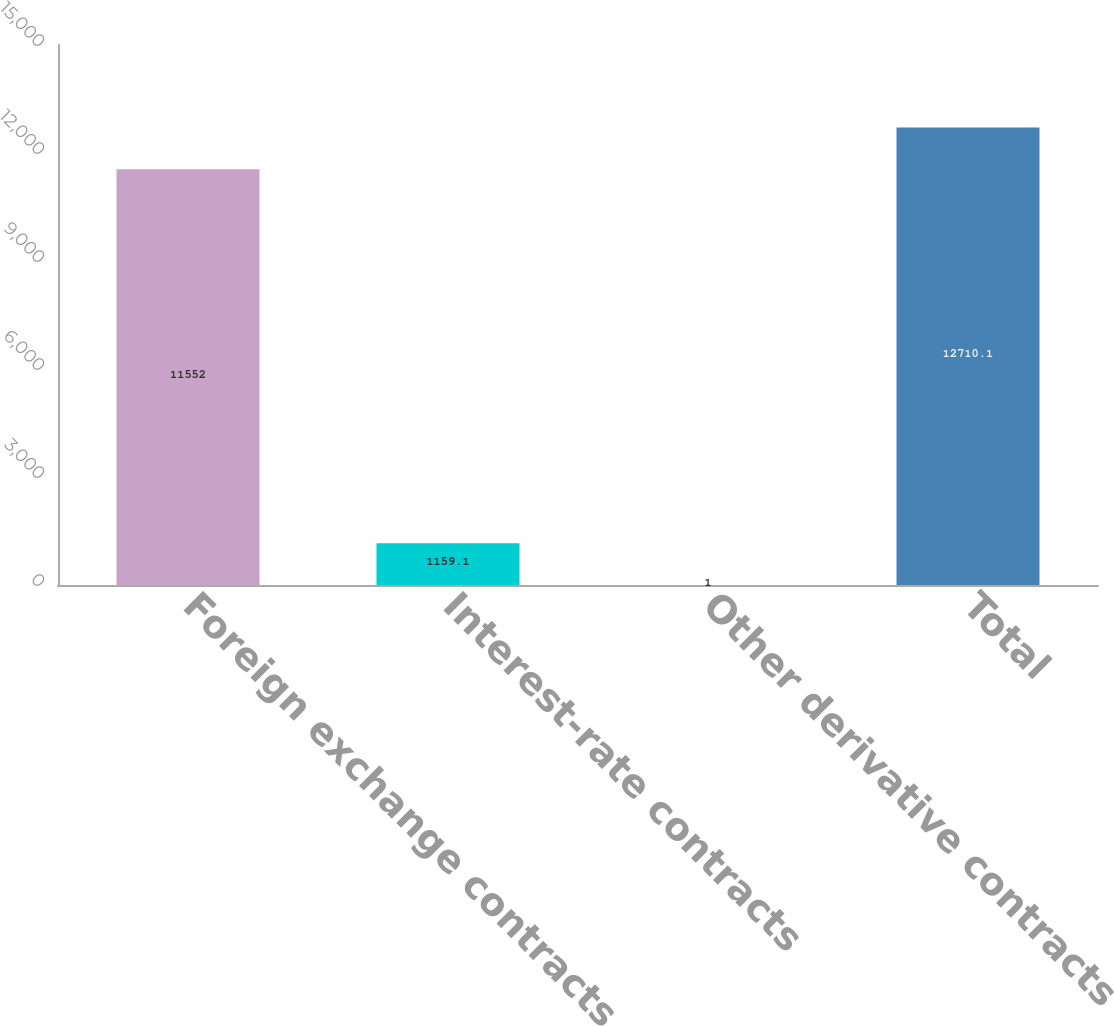Convert chart to OTSL. <chart><loc_0><loc_0><loc_500><loc_500><bar_chart><fcel>Foreign exchange contracts<fcel>Interest-rate contracts<fcel>Other derivative contracts<fcel>Total<nl><fcel>11552<fcel>1159.1<fcel>1<fcel>12710.1<nl></chart> 